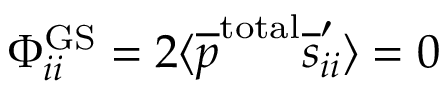Convert formula to latex. <formula><loc_0><loc_0><loc_500><loc_500>\Phi _ { i i } ^ { G S } = 2 \langle \overline { p } ^ { t o t a l } \overline { s } _ { i i } ^ { \prime } \rangle = 0</formula> 